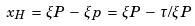<formula> <loc_0><loc_0><loc_500><loc_500>x _ { H } \, = \, \xi P \, - \, \xi p \, = \, \xi P \, - \, \tau / \xi P</formula> 